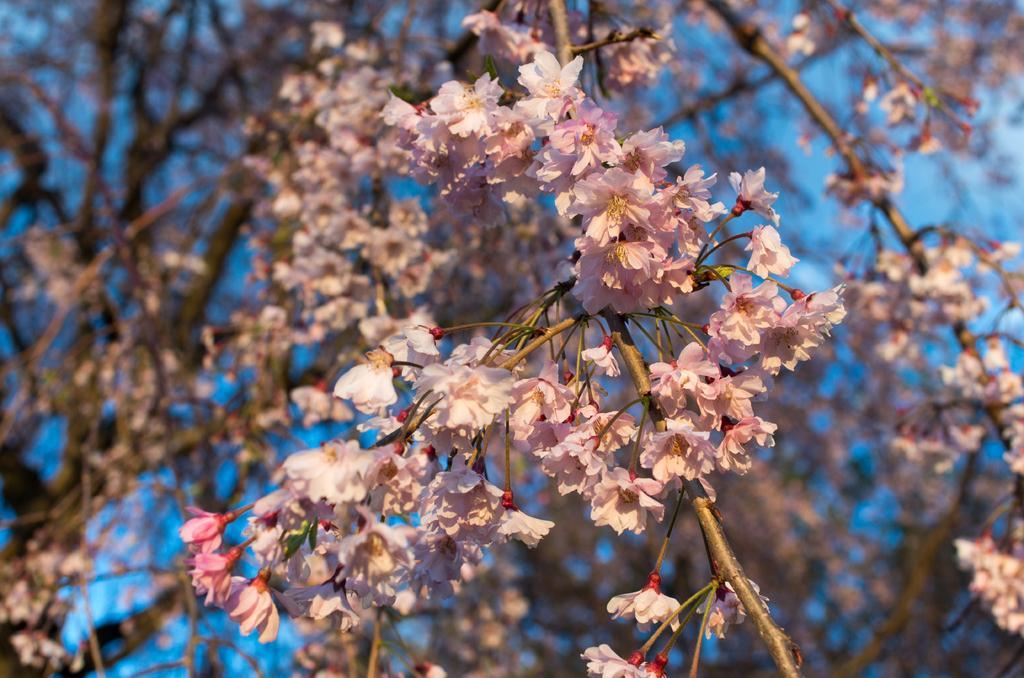Describe this image in one or two sentences. In this image I can see few flowers in pink and white color. In the background the sky is in blue color. 